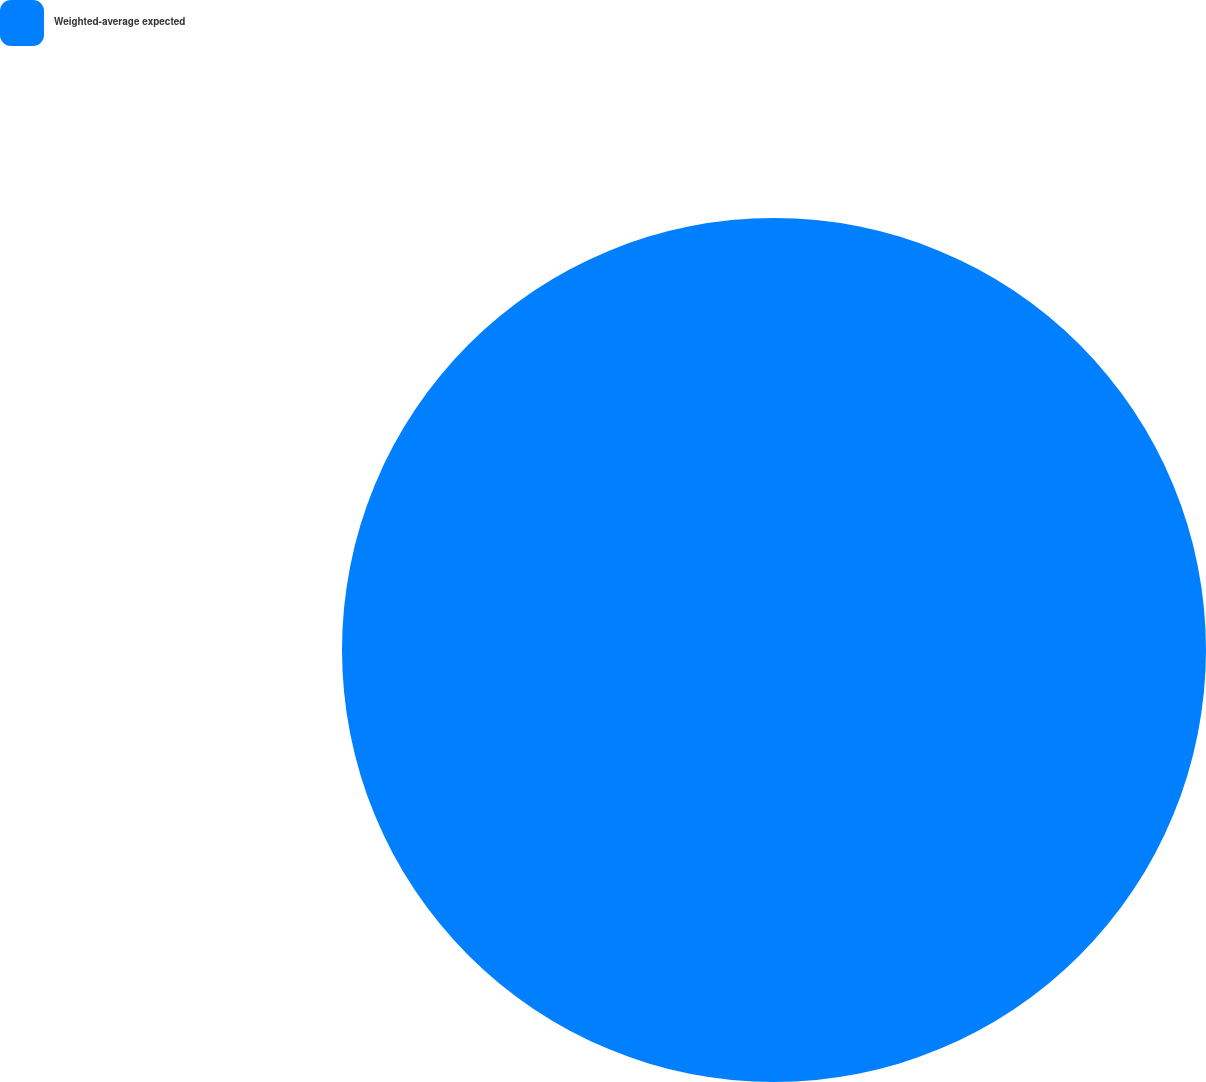Convert chart. <chart><loc_0><loc_0><loc_500><loc_500><pie_chart><fcel>Weighted-average expected<nl><fcel>100.0%<nl></chart> 